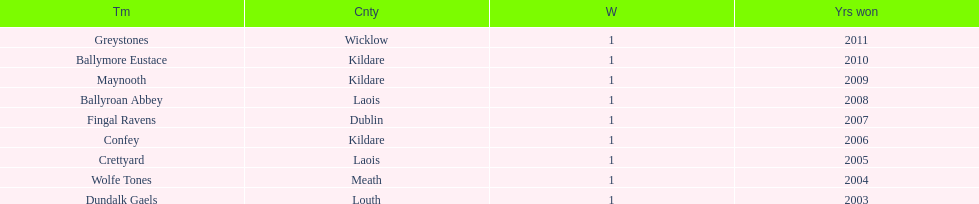For each team, in which years were victories achieved? 2011, 2010, 2009, 2008, 2007, 2006, 2005, 2004, 2003. 